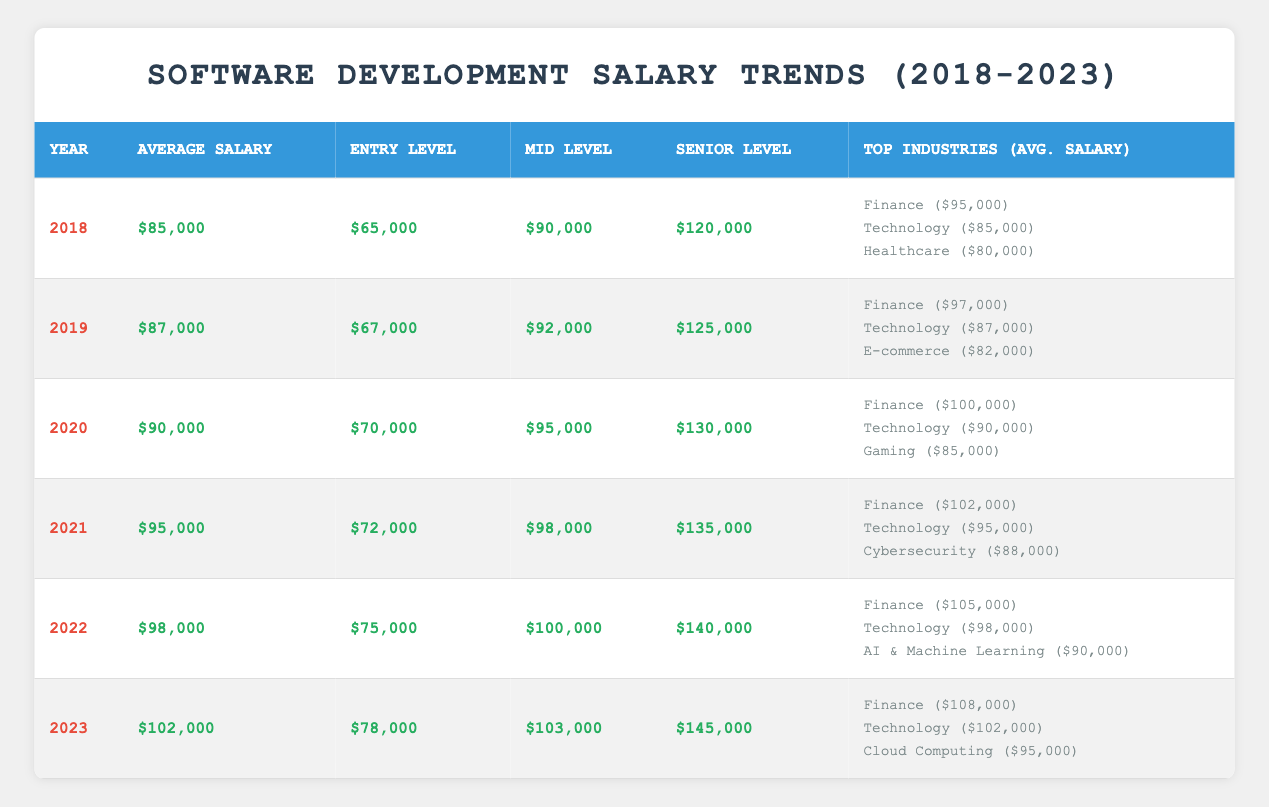What was the average salary in 2021? The table shows that the average salary for 2021 is listed as $95,000.
Answer: $95,000 What was the entry-level salary in 2020? According to the table, the entry-level salary for 2020 is $70,000.
Answer: $70,000 Which industry had the highest average salary in 2022? The table shows that Finance had the highest average salary in 2022 at $105,000, compared to Technology and AI & Machine Learning.
Answer: Finance What is the difference in the senior-level salary between 2018 and 2023? The senior-level salary in 2018 was $120,000 and in 2023 it was $145,000. The difference is $145,000 - $120,000 = $25,000.
Answer: $25,000 What were the average salaries across all years from 2018 to 2023? The average salaries for the years from 2018 to 2023 were $85,000, $87,000, $90,000, $95,000, $98,000, and $102,000. Summing these gives $85,000 + $87,000 + $90,000 + $95,000 + $98,000 + $102,000 = $557,000. Dividing by 6 gives an average of $557,000 / 6 = $92,833.33.
Answer: $92,833.33 Did the entry-level salary increase every year from 2018 to 2023? By examining the entry-level salaries, we see they increased from $65,000 in 2018 to $78,000 in 2023 each year consistently. Therefore, the statement is true.
Answer: Yes Which industry in 2023 had an average salary below $100,000? Looking at the top industries for 2023, both Cloud Computing ($95,000) and Technology ($102,000) are listed. Cloud Computing is the only one below $100,000.
Answer: Cloud Computing What was the percentage increase in the average salary from 2019 to 2021? The average salary in 2019 was $87,000, and in 2021 it was $95,000. The percentage increase is calculated as follows: (($95,000 - $87,000) / $87,000) * 100 = (8,000 / 87,000) * 100 ≈ 9.20%.
Answer: 9.20% What is the average salary in the Finance industry over the years presented? The average salaries for Finance from 2018 to 2023 are $95,000, $97,000, $100,000, $102,000, $105,000, and $108,000. Summing these gives $607,000. Dividing by 6 gives an average of $607,000 / 6 = $101,166.67.
Answer: $101,166.67 Which year had the lowest average salary? The lowest average salary is found by comparing all values listed for each year. The table shows that 2018 had the lowest average salary at $85,000.
Answer: 2018 What was the senior-level salary growth from 2020 to 2022? The senior-level salary increased from $130,000 in 2020 to $140,000 in 2022. The growth is calculated as $140,000 - $130,000 = $10,000.
Answer: $10,000 